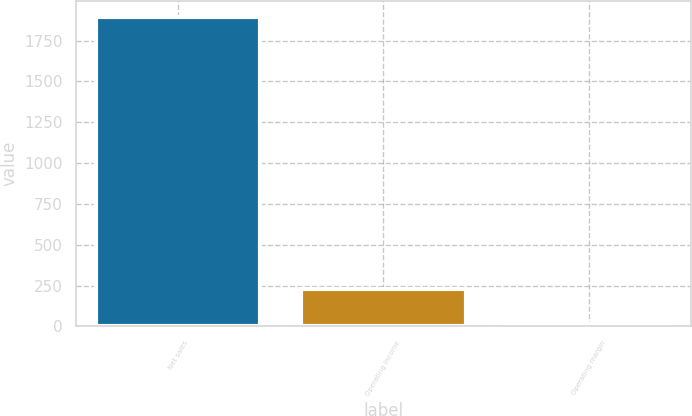Convert chart to OTSL. <chart><loc_0><loc_0><loc_500><loc_500><bar_chart><fcel>Net sales<fcel>Operating income<fcel>Operating margin<nl><fcel>1897<fcel>229<fcel>12.1<nl></chart> 